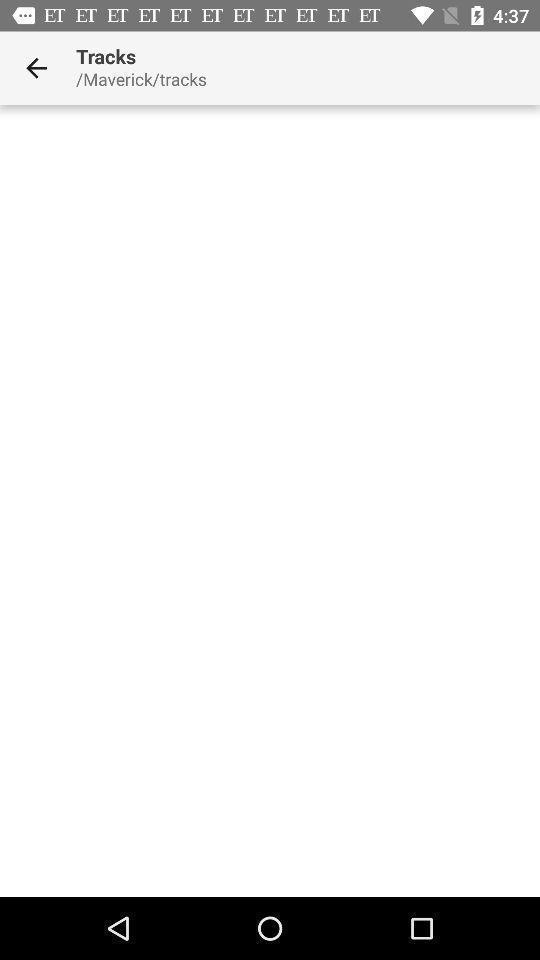Summarize the information in this screenshot. Screen displaying a blank page in a navigation application. 